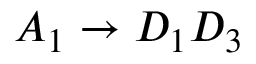Convert formula to latex. <formula><loc_0><loc_0><loc_500><loc_500>A _ { 1 } \rightarrow D _ { 1 } D _ { 3 }</formula> 